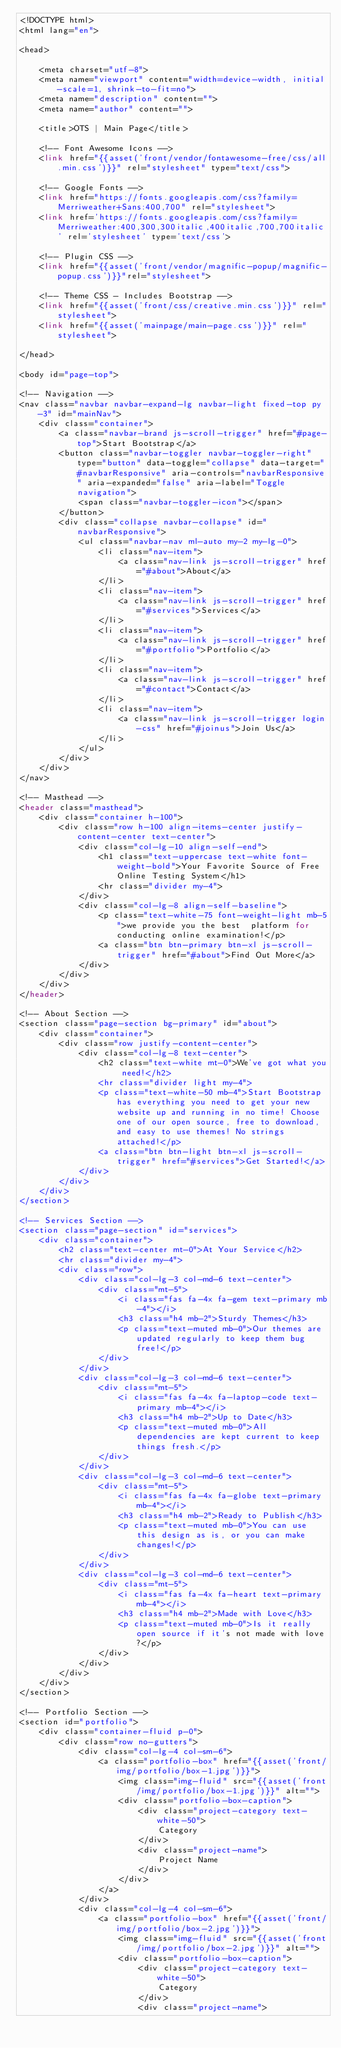<code> <loc_0><loc_0><loc_500><loc_500><_PHP_><!DOCTYPE html>
<html lang="en">

<head>

    <meta charset="utf-8">
    <meta name="viewport" content="width=device-width, initial-scale=1, shrink-to-fit=no">
    <meta name="description" content="">
    <meta name="author" content="">

    <title>OTS | Main Page</title>

    <!-- Font Awesome Icons -->
    <link href="{{asset('front/vendor/fontawesome-free/css/all.min.css')}}" rel="stylesheet" type="text/css">

    <!-- Google Fonts -->
    <link href="https://fonts.googleapis.com/css?family=Merriweather+Sans:400,700" rel="stylesheet">
    <link href='https://fonts.googleapis.com/css?family=Merriweather:400,300,300italic,400italic,700,700italic' rel='stylesheet' type='text/css'>

    <!-- Plugin CSS -->
    <link href="{{asset('front/vendor/magnific-popup/magnific-popup.css')}}"rel="stylesheet">

    <!-- Theme CSS - Includes Bootstrap -->
    <link href="{{asset('front/css/creative.min.css')}}" rel="stylesheet">
    <link href="{{asset('mainpage/main-page.css')}}" rel="stylesheet">

</head>

<body id="page-top">

<!-- Navigation -->
<nav class="navbar navbar-expand-lg navbar-light fixed-top py-3" id="mainNav">
    <div class="container">
        <a class="navbar-brand js-scroll-trigger" href="#page-top">Start Bootstrap</a>
        <button class="navbar-toggler navbar-toggler-right" type="button" data-toggle="collapse" data-target="#navbarResponsive" aria-controls="navbarResponsive" aria-expanded="false" aria-label="Toggle navigation">
            <span class="navbar-toggler-icon"></span>
        </button>
        <div class="collapse navbar-collapse" id="navbarResponsive">
            <ul class="navbar-nav ml-auto my-2 my-lg-0">
                <li class="nav-item">
                    <a class="nav-link js-scroll-trigger" href="#about">About</a>
                </li>
                <li class="nav-item">
                    <a class="nav-link js-scroll-trigger" href="#services">Services</a>
                </li>
                <li class="nav-item">
                    <a class="nav-link js-scroll-trigger" href="#portfolio">Portfolio</a>
                </li>
                <li class="nav-item">
                    <a class="nav-link js-scroll-trigger" href="#contact">Contact</a>
                </li>
                <li class="nav-item">
                    <a class="nav-link js-scroll-trigger login-css" href="#joinus">Join Us</a>
                </li>
            </ul>
        </div>
    </div>
</nav>

<!-- Masthead -->
<header class="masthead">
    <div class="container h-100">
        <div class="row h-100 align-items-center justify-content-center text-center">
            <div class="col-lg-10 align-self-end">
                <h1 class="text-uppercase text-white font-weight-bold">Your Favorite Source of Free Online Testing System</h1>
                <hr class="divider my-4">
            </div>
            <div class="col-lg-8 align-self-baseline">
                <p class="text-white-75 font-weight-light mb-5">we provide you the best  platform for conducting online examination!</p>
                <a class="btn btn-primary btn-xl js-scroll-trigger" href="#about">Find Out More</a>
            </div>
        </div>
    </div>
</header>

<!-- About Section -->
<section class="page-section bg-primary" id="about">
    <div class="container">
        <div class="row justify-content-center">
            <div class="col-lg-8 text-center">
                <h2 class="text-white mt-0">We've got what you need!</h2>
                <hr class="divider light my-4">
                <p class="text-white-50 mb-4">Start Bootstrap has everything you need to get your new website up and running in no time! Choose one of our open source, free to download, and easy to use themes! No strings attached!</p>
                <a class="btn btn-light btn-xl js-scroll-trigger" href="#services">Get Started!</a>
            </div>
        </div>
    </div>
</section>

<!-- Services Section -->
<section class="page-section" id="services">
    <div class="container">
        <h2 class="text-center mt-0">At Your Service</h2>
        <hr class="divider my-4">
        <div class="row">
            <div class="col-lg-3 col-md-6 text-center">
                <div class="mt-5">
                    <i class="fas fa-4x fa-gem text-primary mb-4"></i>
                    <h3 class="h4 mb-2">Sturdy Themes</h3>
                    <p class="text-muted mb-0">Our themes are updated regularly to keep them bug free!</p>
                </div>
            </div>
            <div class="col-lg-3 col-md-6 text-center">
                <div class="mt-5">
                    <i class="fas fa-4x fa-laptop-code text-primary mb-4"></i>
                    <h3 class="h4 mb-2">Up to Date</h3>
                    <p class="text-muted mb-0">All dependencies are kept current to keep things fresh.</p>
                </div>
            </div>
            <div class="col-lg-3 col-md-6 text-center">
                <div class="mt-5">
                    <i class="fas fa-4x fa-globe text-primary mb-4"></i>
                    <h3 class="h4 mb-2">Ready to Publish</h3>
                    <p class="text-muted mb-0">You can use this design as is, or you can make changes!</p>
                </div>
            </div>
            <div class="col-lg-3 col-md-6 text-center">
                <div class="mt-5">
                    <i class="fas fa-4x fa-heart text-primary mb-4"></i>
                    <h3 class="h4 mb-2">Made with Love</h3>
                    <p class="text-muted mb-0">Is it really open source if it's not made with love?</p>
                </div>
            </div>
        </div>
    </div>
</section>

<!-- Portfolio Section -->
<section id="portfolio">
    <div class="container-fluid p-0">
        <div class="row no-gutters">
            <div class="col-lg-4 col-sm-6">
                <a class="portfolio-box" href="{{asset('front/img/portfolio/box-1.jpg')}}">
                    <img class="img-fluid" src="{{asset('front/img/portfolio/box-1.jpg')}}" alt="">
                    <div class="portfolio-box-caption">
                        <div class="project-category text-white-50">
                            Category
                        </div>
                        <div class="project-name">
                            Project Name
                        </div>
                    </div>
                </a>
            </div>
            <div class="col-lg-4 col-sm-6">
                <a class="portfolio-box" href="{{asset('front/img/portfolio/box-2.jpg')}}">
                    <img class="img-fluid" src="{{asset('front/img/portfolio/box-2.jpg')}}" alt="">
                    <div class="portfolio-box-caption">
                        <div class="project-category text-white-50">
                            Category
                        </div>
                        <div class="project-name"></code> 